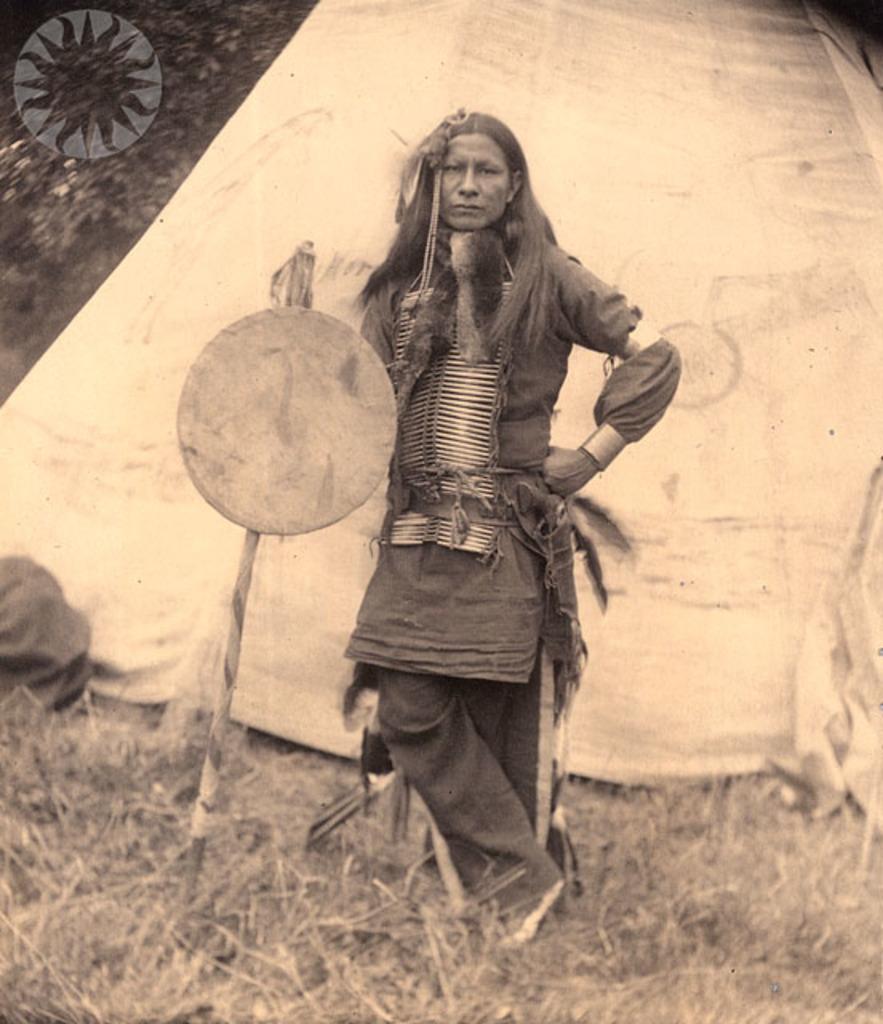Can you describe this image briefly? In this picture we can see a woman standing on the grass, tent, stick, leaves and some objects. 